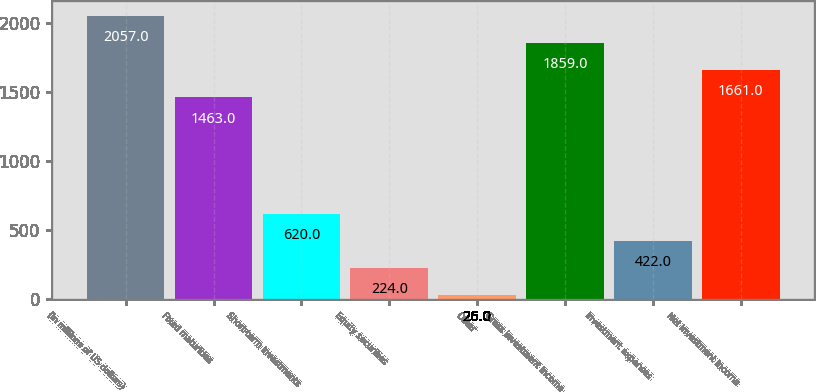Convert chart. <chart><loc_0><loc_0><loc_500><loc_500><bar_chart><fcel>(in millions of US dollars)<fcel>Fixed maturities<fcel>Short-term investments<fcel>Equity securities<fcel>Other<fcel>Gross investment income<fcel>Investment expenses<fcel>Net investment income<nl><fcel>2057<fcel>1463<fcel>620<fcel>224<fcel>26<fcel>1859<fcel>422<fcel>1661<nl></chart> 